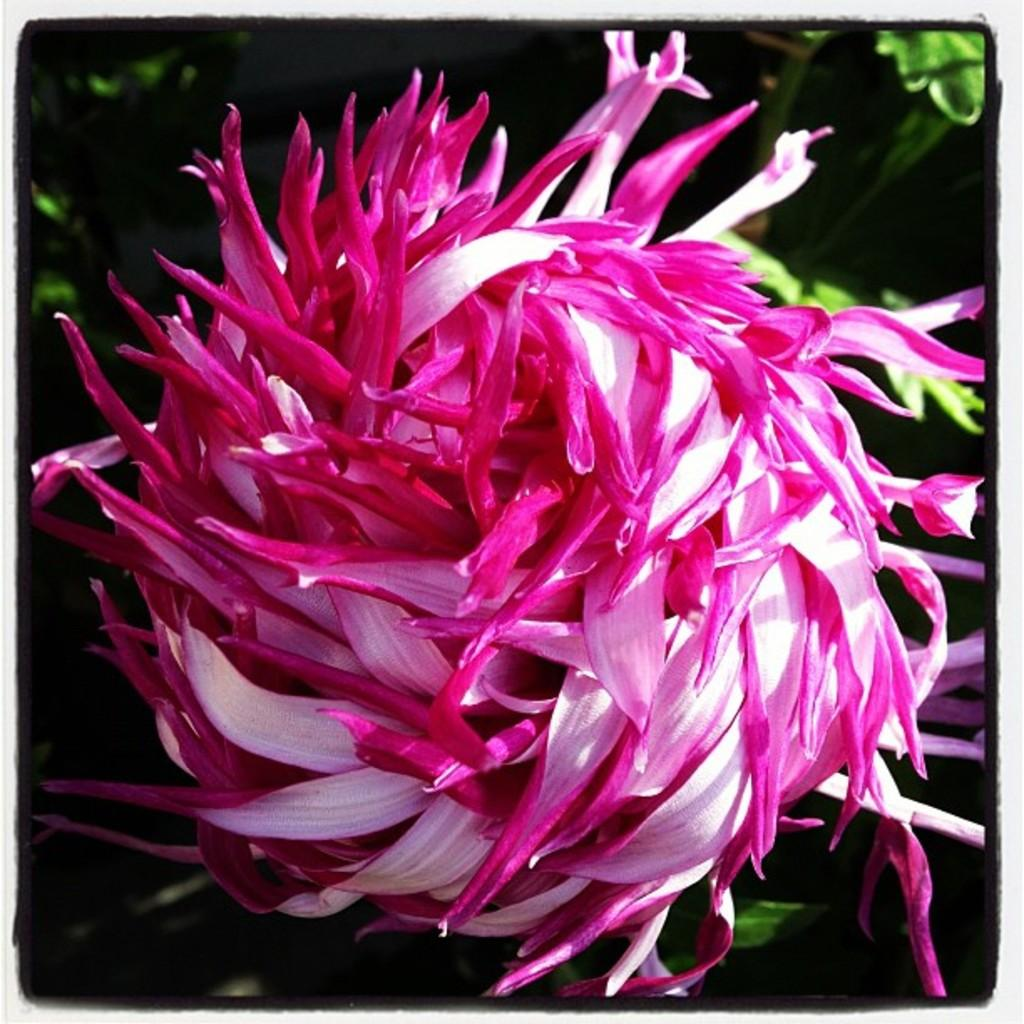What type of plant is visible in the image? There is a flower on a plant in the image. Can you describe the background of the image? The background of the image is dark. What type of team is visible in the image? There is no team present in the image; it features a flower on a plant with a dark background. Can you tell me where the deer is located in the image? There is no deer present in the image. 